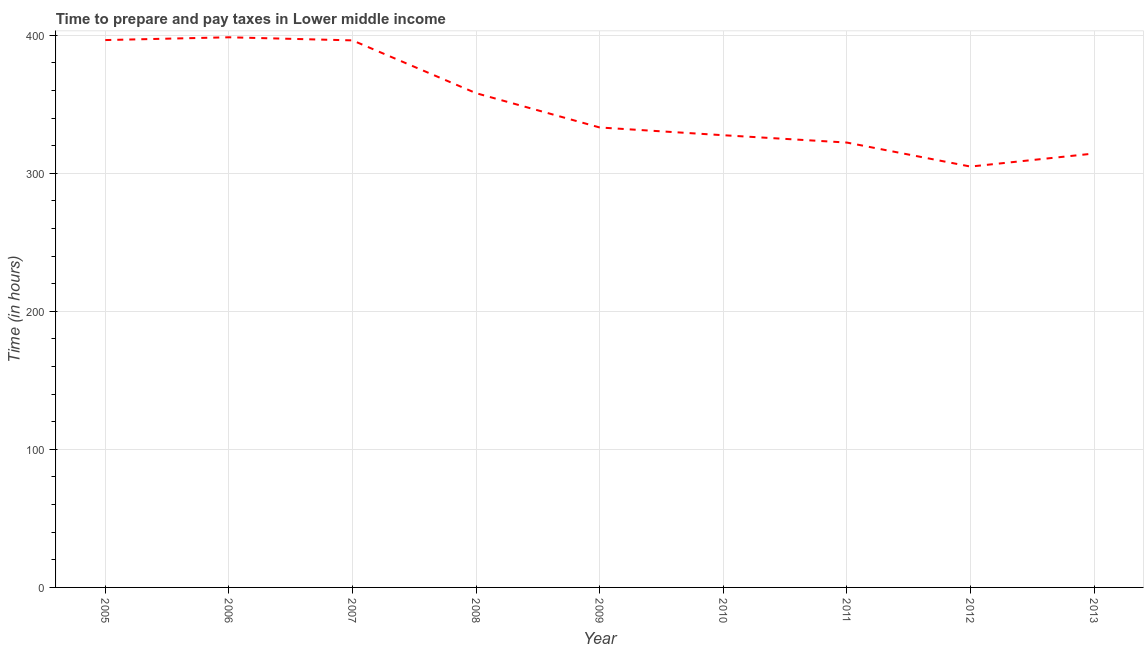What is the time to prepare and pay taxes in 2007?
Give a very brief answer. 396.26. Across all years, what is the maximum time to prepare and pay taxes?
Provide a succinct answer. 398.5. Across all years, what is the minimum time to prepare and pay taxes?
Offer a very short reply. 304.86. In which year was the time to prepare and pay taxes maximum?
Provide a succinct answer. 2006. In which year was the time to prepare and pay taxes minimum?
Give a very brief answer. 2012. What is the sum of the time to prepare and pay taxes?
Provide a short and direct response. 3151.41. What is the difference between the time to prepare and pay taxes in 2007 and 2013?
Provide a short and direct response. 81.95. What is the average time to prepare and pay taxes per year?
Make the answer very short. 350.16. What is the median time to prepare and pay taxes?
Offer a very short reply. 333.17. Do a majority of the years between 2011 and 2007 (inclusive) have time to prepare and pay taxes greater than 300 hours?
Offer a terse response. Yes. What is the ratio of the time to prepare and pay taxes in 2008 to that in 2013?
Your answer should be compact. 1.14. Is the time to prepare and pay taxes in 2005 less than that in 2011?
Offer a terse response. No. What is the difference between the highest and the second highest time to prepare and pay taxes?
Keep it short and to the point. 2.01. Is the sum of the time to prepare and pay taxes in 2005 and 2007 greater than the maximum time to prepare and pay taxes across all years?
Make the answer very short. Yes. What is the difference between the highest and the lowest time to prepare and pay taxes?
Provide a short and direct response. 93.64. Does the time to prepare and pay taxes monotonically increase over the years?
Your response must be concise. No. How many years are there in the graph?
Keep it short and to the point. 9. Are the values on the major ticks of Y-axis written in scientific E-notation?
Your answer should be compact. No. Does the graph contain grids?
Give a very brief answer. Yes. What is the title of the graph?
Your answer should be compact. Time to prepare and pay taxes in Lower middle income. What is the label or title of the Y-axis?
Your response must be concise. Time (in hours). What is the Time (in hours) in 2005?
Offer a very short reply. 396.49. What is the Time (in hours) in 2006?
Offer a terse response. 398.5. What is the Time (in hours) in 2007?
Provide a succinct answer. 396.26. What is the Time (in hours) in 2008?
Your answer should be compact. 358.02. What is the Time (in hours) of 2009?
Offer a terse response. 333.17. What is the Time (in hours) of 2010?
Your response must be concise. 327.56. What is the Time (in hours) of 2011?
Make the answer very short. 322.24. What is the Time (in hours) in 2012?
Provide a short and direct response. 304.86. What is the Time (in hours) in 2013?
Give a very brief answer. 314.31. What is the difference between the Time (in hours) in 2005 and 2006?
Make the answer very short. -2.01. What is the difference between the Time (in hours) in 2005 and 2007?
Provide a short and direct response. 0.23. What is the difference between the Time (in hours) in 2005 and 2008?
Ensure brevity in your answer.  38.47. What is the difference between the Time (in hours) in 2005 and 2009?
Your answer should be compact. 63.32. What is the difference between the Time (in hours) in 2005 and 2010?
Provide a succinct answer. 68.93. What is the difference between the Time (in hours) in 2005 and 2011?
Offer a very short reply. 74.24. What is the difference between the Time (in hours) in 2005 and 2012?
Ensure brevity in your answer.  91.63. What is the difference between the Time (in hours) in 2005 and 2013?
Provide a succinct answer. 82.18. What is the difference between the Time (in hours) in 2006 and 2007?
Your response must be concise. 2.24. What is the difference between the Time (in hours) in 2006 and 2008?
Provide a succinct answer. 40.48. What is the difference between the Time (in hours) in 2006 and 2009?
Keep it short and to the point. 65.33. What is the difference between the Time (in hours) in 2006 and 2010?
Ensure brevity in your answer.  70.94. What is the difference between the Time (in hours) in 2006 and 2011?
Make the answer very short. 76.26. What is the difference between the Time (in hours) in 2006 and 2012?
Offer a very short reply. 93.64. What is the difference between the Time (in hours) in 2006 and 2013?
Your answer should be compact. 84.19. What is the difference between the Time (in hours) in 2007 and 2008?
Give a very brief answer. 38.25. What is the difference between the Time (in hours) in 2007 and 2009?
Give a very brief answer. 63.09. What is the difference between the Time (in hours) in 2007 and 2010?
Your answer should be compact. 68.7. What is the difference between the Time (in hours) in 2007 and 2011?
Give a very brief answer. 74.02. What is the difference between the Time (in hours) in 2007 and 2012?
Provide a short and direct response. 91.4. What is the difference between the Time (in hours) in 2007 and 2013?
Offer a terse response. 81.95. What is the difference between the Time (in hours) in 2008 and 2009?
Provide a succinct answer. 24.84. What is the difference between the Time (in hours) in 2008 and 2010?
Offer a terse response. 30.45. What is the difference between the Time (in hours) in 2008 and 2011?
Give a very brief answer. 35.77. What is the difference between the Time (in hours) in 2008 and 2012?
Your response must be concise. 53.16. What is the difference between the Time (in hours) in 2008 and 2013?
Provide a succinct answer. 43.7. What is the difference between the Time (in hours) in 2009 and 2010?
Offer a terse response. 5.61. What is the difference between the Time (in hours) in 2009 and 2011?
Give a very brief answer. 10.93. What is the difference between the Time (in hours) in 2009 and 2012?
Your response must be concise. 28.31. What is the difference between the Time (in hours) in 2009 and 2013?
Provide a short and direct response. 18.86. What is the difference between the Time (in hours) in 2010 and 2011?
Your response must be concise. 5.32. What is the difference between the Time (in hours) in 2010 and 2012?
Give a very brief answer. 22.7. What is the difference between the Time (in hours) in 2010 and 2013?
Make the answer very short. 13.25. What is the difference between the Time (in hours) in 2011 and 2012?
Give a very brief answer. 17.39. What is the difference between the Time (in hours) in 2011 and 2013?
Ensure brevity in your answer.  7.93. What is the difference between the Time (in hours) in 2012 and 2013?
Your response must be concise. -9.45. What is the ratio of the Time (in hours) in 2005 to that in 2006?
Make the answer very short. 0.99. What is the ratio of the Time (in hours) in 2005 to that in 2008?
Provide a short and direct response. 1.11. What is the ratio of the Time (in hours) in 2005 to that in 2009?
Your answer should be compact. 1.19. What is the ratio of the Time (in hours) in 2005 to that in 2010?
Ensure brevity in your answer.  1.21. What is the ratio of the Time (in hours) in 2005 to that in 2011?
Provide a short and direct response. 1.23. What is the ratio of the Time (in hours) in 2005 to that in 2012?
Keep it short and to the point. 1.3. What is the ratio of the Time (in hours) in 2005 to that in 2013?
Provide a short and direct response. 1.26. What is the ratio of the Time (in hours) in 2006 to that in 2008?
Offer a very short reply. 1.11. What is the ratio of the Time (in hours) in 2006 to that in 2009?
Offer a very short reply. 1.2. What is the ratio of the Time (in hours) in 2006 to that in 2010?
Your answer should be compact. 1.22. What is the ratio of the Time (in hours) in 2006 to that in 2011?
Your answer should be compact. 1.24. What is the ratio of the Time (in hours) in 2006 to that in 2012?
Your answer should be compact. 1.31. What is the ratio of the Time (in hours) in 2006 to that in 2013?
Give a very brief answer. 1.27. What is the ratio of the Time (in hours) in 2007 to that in 2008?
Give a very brief answer. 1.11. What is the ratio of the Time (in hours) in 2007 to that in 2009?
Your answer should be compact. 1.19. What is the ratio of the Time (in hours) in 2007 to that in 2010?
Provide a short and direct response. 1.21. What is the ratio of the Time (in hours) in 2007 to that in 2011?
Offer a terse response. 1.23. What is the ratio of the Time (in hours) in 2007 to that in 2012?
Offer a terse response. 1.3. What is the ratio of the Time (in hours) in 2007 to that in 2013?
Give a very brief answer. 1.26. What is the ratio of the Time (in hours) in 2008 to that in 2009?
Provide a short and direct response. 1.07. What is the ratio of the Time (in hours) in 2008 to that in 2010?
Offer a very short reply. 1.09. What is the ratio of the Time (in hours) in 2008 to that in 2011?
Offer a very short reply. 1.11. What is the ratio of the Time (in hours) in 2008 to that in 2012?
Make the answer very short. 1.17. What is the ratio of the Time (in hours) in 2008 to that in 2013?
Your response must be concise. 1.14. What is the ratio of the Time (in hours) in 2009 to that in 2010?
Your answer should be compact. 1.02. What is the ratio of the Time (in hours) in 2009 to that in 2011?
Keep it short and to the point. 1.03. What is the ratio of the Time (in hours) in 2009 to that in 2012?
Make the answer very short. 1.09. What is the ratio of the Time (in hours) in 2009 to that in 2013?
Make the answer very short. 1.06. What is the ratio of the Time (in hours) in 2010 to that in 2012?
Your response must be concise. 1.07. What is the ratio of the Time (in hours) in 2010 to that in 2013?
Your answer should be compact. 1.04. What is the ratio of the Time (in hours) in 2011 to that in 2012?
Make the answer very short. 1.06. What is the ratio of the Time (in hours) in 2012 to that in 2013?
Make the answer very short. 0.97. 